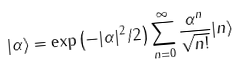Convert formula to latex. <formula><loc_0><loc_0><loc_500><loc_500>| \alpha \rangle = \exp \left ( - | \alpha | ^ { 2 } / 2 \right ) \sum _ { n = 0 } ^ { \infty } \frac { \alpha ^ { n } } { \sqrt { n ! } } | n \rangle</formula> 